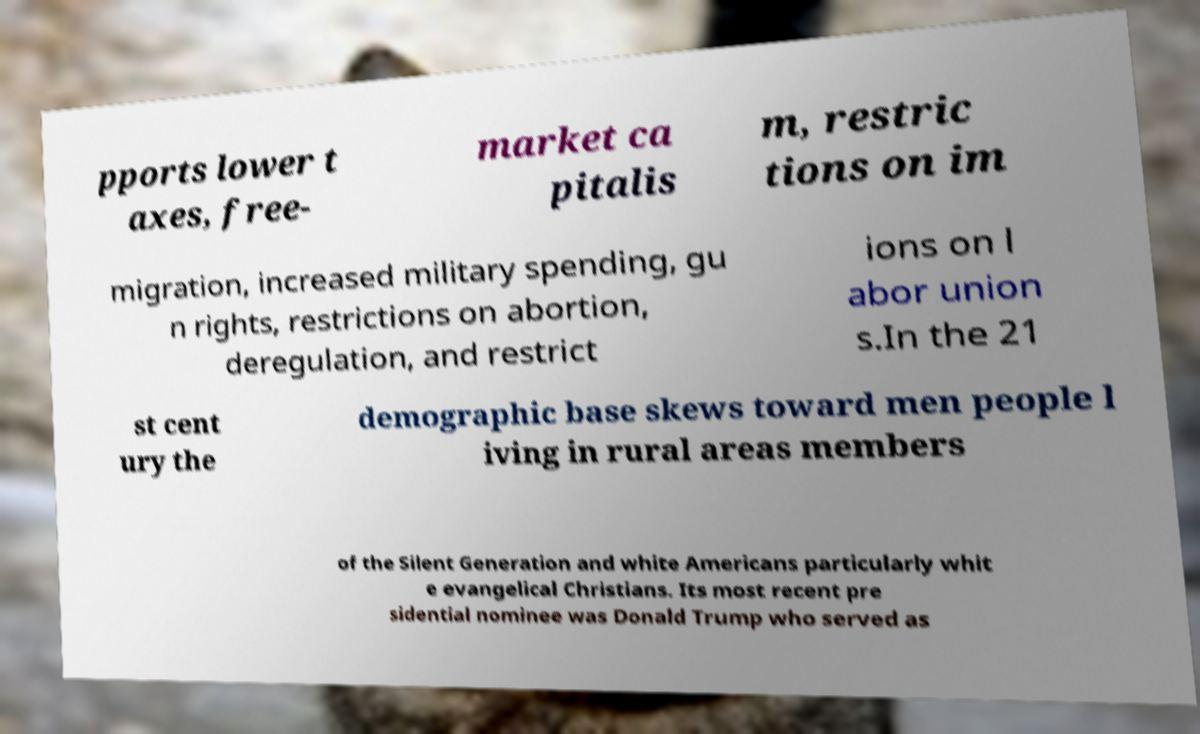For documentation purposes, I need the text within this image transcribed. Could you provide that? pports lower t axes, free- market ca pitalis m, restric tions on im migration, increased military spending, gu n rights, restrictions on abortion, deregulation, and restrict ions on l abor union s.In the 21 st cent ury the demographic base skews toward men people l iving in rural areas members of the Silent Generation and white Americans particularly whit e evangelical Christians. Its most recent pre sidential nominee was Donald Trump who served as 